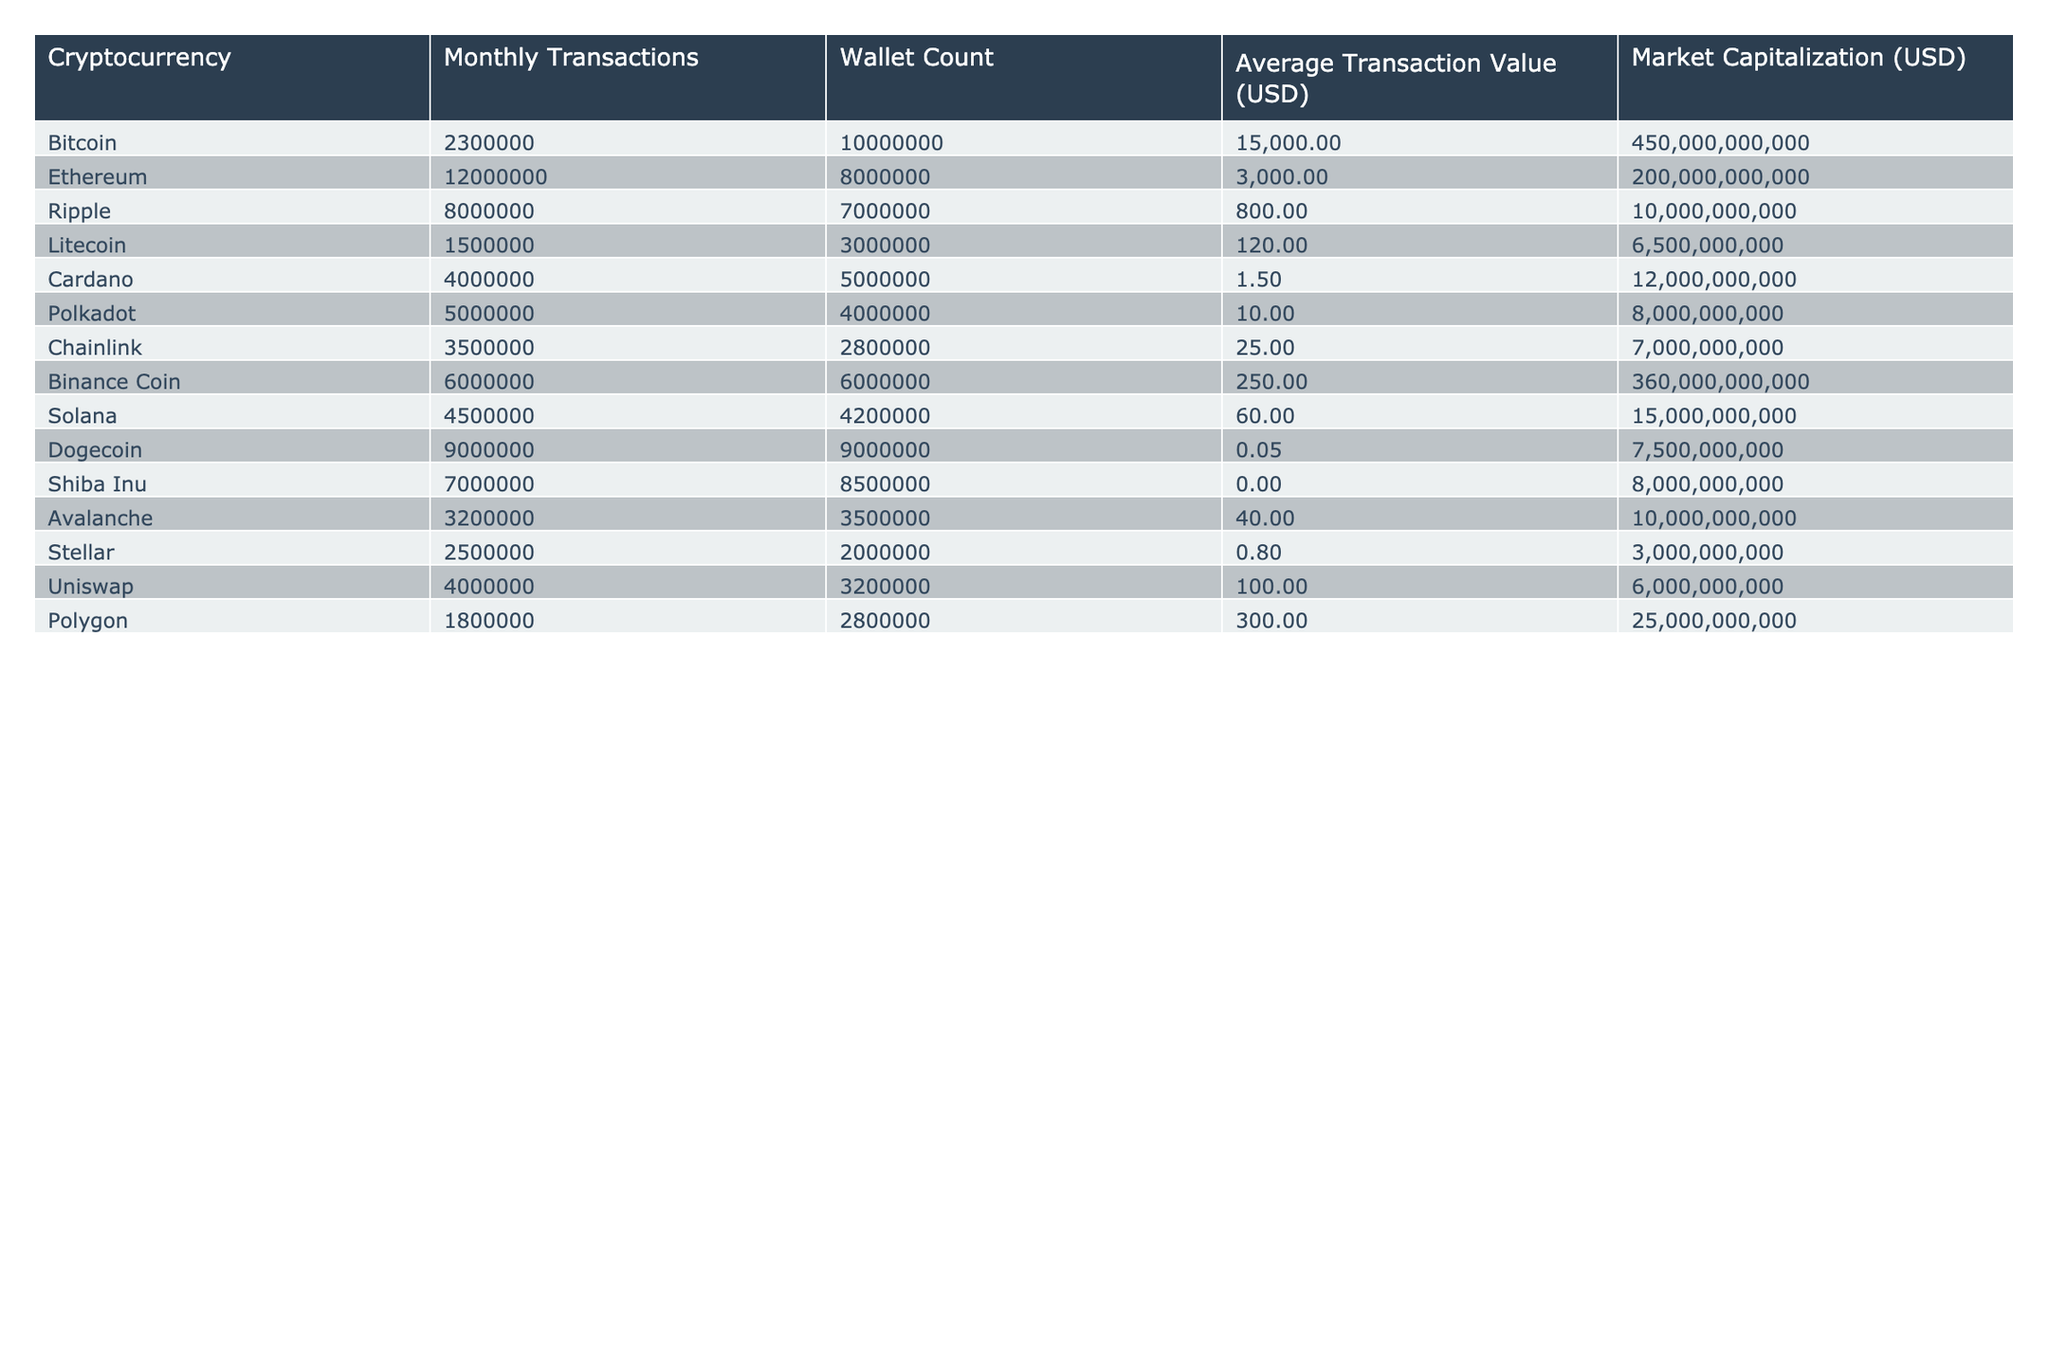What is the cryptocurrency with the highest monthly transactions? By looking at the "Monthly Transactions" column, Bitcoin has 2,300,000 transactions which is less than Ethereum's 12,000,000 transactions, making Ethereum the highest.
Answer: Ethereum Which cryptocurrency has the lowest average transaction value? The "Average Transaction Value (USD)" column shows that Cardano has the lowest value at 1.50 USD.
Answer: Cardano How many wallets does Binance Coin have? The "Wallet Count" column indicates that Binance Coin has 6,000,000 wallets.
Answer: 6,000,000 What is the total number of wallets across all the listed cryptocurrencies? Adding the values in the "Wallet Count" column gives: 10,000,000 + 8,000,000 + 7,000,000 + 3,000,000 + 5,000,000 + 4,000,000 + 2,800,000 + 6,000,000 + 4,200,000 + 9,000,000 + 8,500,000 + 3,500,000 + 2,000,000 + 3,200,000 + 2,800,000 =  74,200,000.
Answer: 74,200,000 Is the average transaction value of Dogecoin greater than that of Ripple? The "Average Transaction Value (USD)" for Dogecoin is 0.05, which is less than Ripple's 800. Therefore, this is false.
Answer: No Which two cryptocurrencies have a combined monthly transaction count greater than 10 million? When you add Ethereum's 12,000,000 to Ripple's 8,000,000, you get 20,000,000, which is greater than 10,000,000. Thus, Ethereum and Ripple combined fit the criteria.
Answer: Ethereum and Ripple What is the average monthly transaction count for the top four cryptocurrencies by wallet count? The top four cryptocurrencies by wallet count are Bitcoin, Ethereum, Binance Coin, and Dogecoin. Their monthly transactions are 2,300,000, 12,000,000, 6,000,000, and 9,000,000 respectively; adding them gives 29,300,000, and dividing by 4 gives an average of 7,325,000.
Answer: 7,325,000 Which cryptocurrency has more wallets, Cardano or Stellar? The "Wallet Count" column shows Cardano has 5,000,000 wallets and Stellar has 2,000,000 wallets. Therefore, Cardano has more wallets than Stellar.
Answer: Cardano What is the market capitalization difference between Ethereum and Dogecoin? The "Market Capitalization" for Ethereum is 200,000,000,000 and for Dogecoin it is 7,500,000,000. The difference is 200,000,000,000 - 7,500,000,000 = 192,500,000,000.
Answer: 192,500,000,000 Which cryptocurrency has the second highest wallet count and how many wallets does it have? Looking at the "Wallet Count" column, the highest is Bitcoin with 10,000,000, and the second highest is Dogecoin with 9,000,000 wallets.
Answer: Dogecoin, 9,000,000 